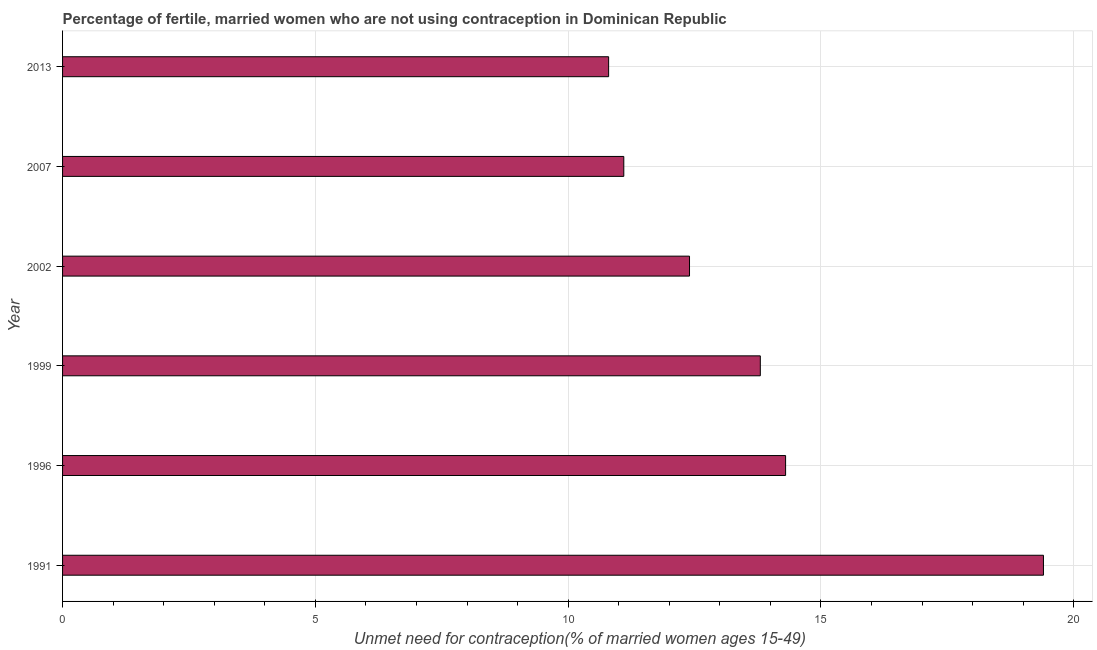Does the graph contain grids?
Your answer should be compact. Yes. What is the title of the graph?
Make the answer very short. Percentage of fertile, married women who are not using contraception in Dominican Republic. What is the label or title of the X-axis?
Provide a short and direct response.  Unmet need for contraception(% of married women ages 15-49). What is the label or title of the Y-axis?
Keep it short and to the point. Year. Across all years, what is the minimum number of married women who are not using contraception?
Your answer should be very brief. 10.8. In which year was the number of married women who are not using contraception maximum?
Keep it short and to the point. 1991. In which year was the number of married women who are not using contraception minimum?
Give a very brief answer. 2013. What is the sum of the number of married women who are not using contraception?
Ensure brevity in your answer.  81.8. What is the difference between the number of married women who are not using contraception in 1996 and 2013?
Ensure brevity in your answer.  3.5. What is the average number of married women who are not using contraception per year?
Keep it short and to the point. 13.63. What is the median number of married women who are not using contraception?
Keep it short and to the point. 13.1. In how many years, is the number of married women who are not using contraception greater than 18 %?
Your answer should be very brief. 1. What is the ratio of the number of married women who are not using contraception in 1999 to that in 2013?
Offer a terse response. 1.28. Is the number of married women who are not using contraception in 1999 less than that in 2013?
Provide a short and direct response. No. What is the difference between the highest and the second highest number of married women who are not using contraception?
Your response must be concise. 5.1. What is the difference between the highest and the lowest number of married women who are not using contraception?
Your answer should be compact. 8.6. How many bars are there?
Your response must be concise. 6. Are all the bars in the graph horizontal?
Make the answer very short. Yes. How many years are there in the graph?
Your response must be concise. 6. What is the difference between two consecutive major ticks on the X-axis?
Your response must be concise. 5. What is the  Unmet need for contraception(% of married women ages 15-49) in 1991?
Offer a terse response. 19.4. What is the  Unmet need for contraception(% of married women ages 15-49) in 1999?
Offer a terse response. 13.8. What is the  Unmet need for contraception(% of married women ages 15-49) of 2007?
Your response must be concise. 11.1. What is the difference between the  Unmet need for contraception(% of married women ages 15-49) in 1991 and 1996?
Keep it short and to the point. 5.1. What is the difference between the  Unmet need for contraception(% of married women ages 15-49) in 1996 and 1999?
Offer a very short reply. 0.5. What is the difference between the  Unmet need for contraception(% of married women ages 15-49) in 1996 and 2002?
Your response must be concise. 1.9. What is the difference between the  Unmet need for contraception(% of married women ages 15-49) in 1996 and 2007?
Ensure brevity in your answer.  3.2. What is the difference between the  Unmet need for contraception(% of married women ages 15-49) in 1999 and 2007?
Your answer should be compact. 2.7. What is the difference between the  Unmet need for contraception(% of married women ages 15-49) in 1999 and 2013?
Ensure brevity in your answer.  3. What is the difference between the  Unmet need for contraception(% of married women ages 15-49) in 2002 and 2013?
Offer a very short reply. 1.6. What is the difference between the  Unmet need for contraception(% of married women ages 15-49) in 2007 and 2013?
Provide a succinct answer. 0.3. What is the ratio of the  Unmet need for contraception(% of married women ages 15-49) in 1991 to that in 1996?
Give a very brief answer. 1.36. What is the ratio of the  Unmet need for contraception(% of married women ages 15-49) in 1991 to that in 1999?
Give a very brief answer. 1.41. What is the ratio of the  Unmet need for contraception(% of married women ages 15-49) in 1991 to that in 2002?
Keep it short and to the point. 1.56. What is the ratio of the  Unmet need for contraception(% of married women ages 15-49) in 1991 to that in 2007?
Keep it short and to the point. 1.75. What is the ratio of the  Unmet need for contraception(% of married women ages 15-49) in 1991 to that in 2013?
Provide a short and direct response. 1.8. What is the ratio of the  Unmet need for contraception(% of married women ages 15-49) in 1996 to that in 1999?
Keep it short and to the point. 1.04. What is the ratio of the  Unmet need for contraception(% of married women ages 15-49) in 1996 to that in 2002?
Provide a succinct answer. 1.15. What is the ratio of the  Unmet need for contraception(% of married women ages 15-49) in 1996 to that in 2007?
Keep it short and to the point. 1.29. What is the ratio of the  Unmet need for contraception(% of married women ages 15-49) in 1996 to that in 2013?
Your response must be concise. 1.32. What is the ratio of the  Unmet need for contraception(% of married women ages 15-49) in 1999 to that in 2002?
Offer a terse response. 1.11. What is the ratio of the  Unmet need for contraception(% of married women ages 15-49) in 1999 to that in 2007?
Your response must be concise. 1.24. What is the ratio of the  Unmet need for contraception(% of married women ages 15-49) in 1999 to that in 2013?
Give a very brief answer. 1.28. What is the ratio of the  Unmet need for contraception(% of married women ages 15-49) in 2002 to that in 2007?
Give a very brief answer. 1.12. What is the ratio of the  Unmet need for contraception(% of married women ages 15-49) in 2002 to that in 2013?
Make the answer very short. 1.15. What is the ratio of the  Unmet need for contraception(% of married women ages 15-49) in 2007 to that in 2013?
Provide a short and direct response. 1.03. 